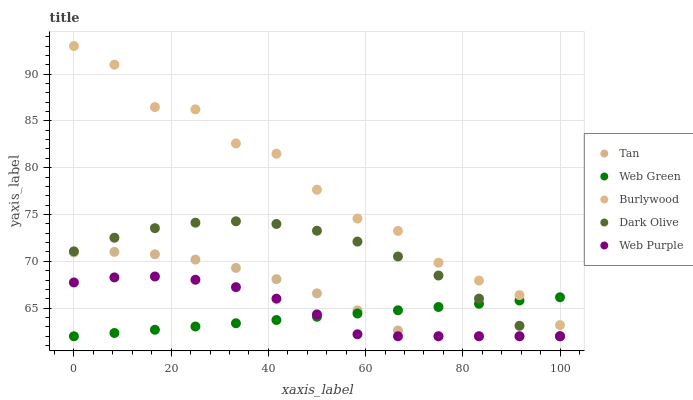Does Web Green have the minimum area under the curve?
Answer yes or no. Yes. Does Burlywood have the maximum area under the curve?
Answer yes or no. Yes. Does Tan have the minimum area under the curve?
Answer yes or no. No. Does Tan have the maximum area under the curve?
Answer yes or no. No. Is Web Green the smoothest?
Answer yes or no. Yes. Is Burlywood the roughest?
Answer yes or no. Yes. Is Tan the smoothest?
Answer yes or no. No. Is Tan the roughest?
Answer yes or no. No. Does Tan have the lowest value?
Answer yes or no. Yes. Does Burlywood have the highest value?
Answer yes or no. Yes. Does Tan have the highest value?
Answer yes or no. No. Is Tan less than Burlywood?
Answer yes or no. Yes. Is Burlywood greater than Tan?
Answer yes or no. Yes. Does Burlywood intersect Web Green?
Answer yes or no. Yes. Is Burlywood less than Web Green?
Answer yes or no. No. Is Burlywood greater than Web Green?
Answer yes or no. No. Does Tan intersect Burlywood?
Answer yes or no. No. 